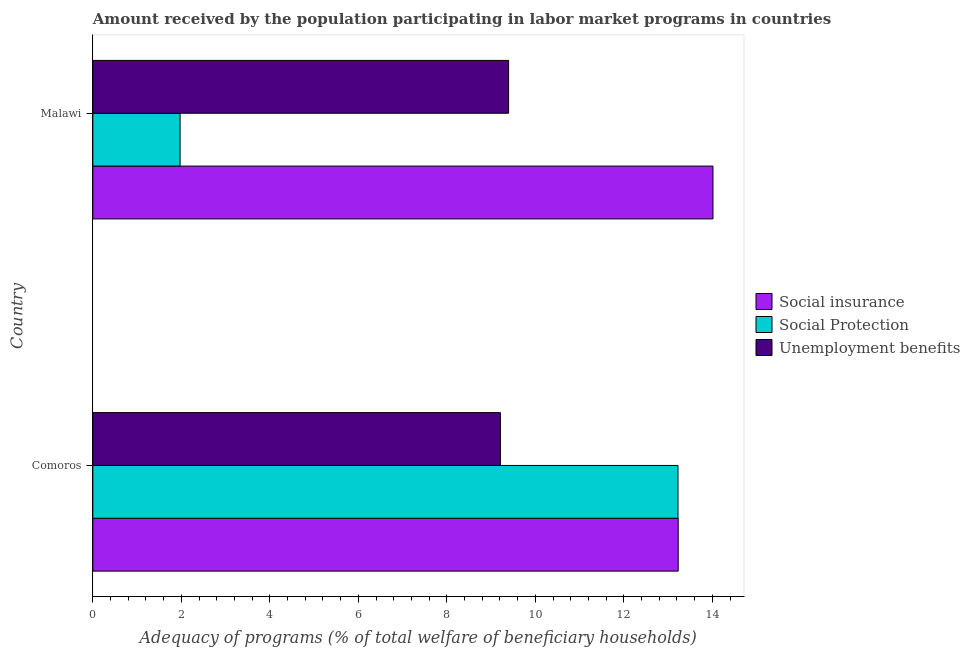How many different coloured bars are there?
Your answer should be compact. 3. How many groups of bars are there?
Keep it short and to the point. 2. Are the number of bars per tick equal to the number of legend labels?
Your answer should be very brief. Yes. How many bars are there on the 1st tick from the top?
Offer a terse response. 3. What is the label of the 1st group of bars from the top?
Offer a very short reply. Malawi. In how many cases, is the number of bars for a given country not equal to the number of legend labels?
Your answer should be very brief. 0. What is the amount received by the population participating in social protection programs in Malawi?
Offer a terse response. 1.97. Across all countries, what is the maximum amount received by the population participating in unemployment benefits programs?
Offer a very short reply. 9.4. Across all countries, what is the minimum amount received by the population participating in unemployment benefits programs?
Your response must be concise. 9.21. In which country was the amount received by the population participating in social protection programs maximum?
Make the answer very short. Comoros. In which country was the amount received by the population participating in social insurance programs minimum?
Your answer should be compact. Comoros. What is the total amount received by the population participating in unemployment benefits programs in the graph?
Make the answer very short. 18.61. What is the difference between the amount received by the population participating in unemployment benefits programs in Comoros and that in Malawi?
Make the answer very short. -0.19. What is the difference between the amount received by the population participating in social insurance programs in Comoros and the amount received by the population participating in unemployment benefits programs in Malawi?
Your answer should be compact. 3.83. What is the average amount received by the population participating in unemployment benefits programs per country?
Keep it short and to the point. 9.3. What is the difference between the amount received by the population participating in social protection programs and amount received by the population participating in unemployment benefits programs in Malawi?
Your answer should be very brief. -7.42. What is the ratio of the amount received by the population participating in social insurance programs in Comoros to that in Malawi?
Your answer should be compact. 0.94. Is the amount received by the population participating in social protection programs in Comoros less than that in Malawi?
Your answer should be compact. No. In how many countries, is the amount received by the population participating in social insurance programs greater than the average amount received by the population participating in social insurance programs taken over all countries?
Offer a very short reply. 1. What does the 2nd bar from the top in Comoros represents?
Your answer should be very brief. Social Protection. What does the 3rd bar from the bottom in Malawi represents?
Provide a short and direct response. Unemployment benefits. Are all the bars in the graph horizontal?
Offer a very short reply. Yes. How many countries are there in the graph?
Give a very brief answer. 2. Are the values on the major ticks of X-axis written in scientific E-notation?
Provide a short and direct response. No. Where does the legend appear in the graph?
Ensure brevity in your answer.  Center right. How are the legend labels stacked?
Provide a short and direct response. Vertical. What is the title of the graph?
Give a very brief answer. Amount received by the population participating in labor market programs in countries. Does "Social Protection and Labor" appear as one of the legend labels in the graph?
Offer a terse response. No. What is the label or title of the X-axis?
Your answer should be very brief. Adequacy of programs (% of total welfare of beneficiary households). What is the label or title of the Y-axis?
Give a very brief answer. Country. What is the Adequacy of programs (% of total welfare of beneficiary households) of Social insurance in Comoros?
Make the answer very short. 13.23. What is the Adequacy of programs (% of total welfare of beneficiary households) in Social Protection in Comoros?
Offer a very short reply. 13.22. What is the Adequacy of programs (% of total welfare of beneficiary households) in Unemployment benefits in Comoros?
Provide a short and direct response. 9.21. What is the Adequacy of programs (% of total welfare of beneficiary households) of Social insurance in Malawi?
Provide a succinct answer. 14.02. What is the Adequacy of programs (% of total welfare of beneficiary households) of Social Protection in Malawi?
Keep it short and to the point. 1.97. What is the Adequacy of programs (% of total welfare of beneficiary households) in Unemployment benefits in Malawi?
Your response must be concise. 9.4. Across all countries, what is the maximum Adequacy of programs (% of total welfare of beneficiary households) of Social insurance?
Provide a short and direct response. 14.02. Across all countries, what is the maximum Adequacy of programs (% of total welfare of beneficiary households) in Social Protection?
Your answer should be compact. 13.22. Across all countries, what is the maximum Adequacy of programs (% of total welfare of beneficiary households) of Unemployment benefits?
Ensure brevity in your answer.  9.4. Across all countries, what is the minimum Adequacy of programs (% of total welfare of beneficiary households) of Social insurance?
Provide a succinct answer. 13.23. Across all countries, what is the minimum Adequacy of programs (% of total welfare of beneficiary households) in Social Protection?
Ensure brevity in your answer.  1.97. Across all countries, what is the minimum Adequacy of programs (% of total welfare of beneficiary households) of Unemployment benefits?
Your response must be concise. 9.21. What is the total Adequacy of programs (% of total welfare of beneficiary households) of Social insurance in the graph?
Offer a terse response. 27.24. What is the total Adequacy of programs (% of total welfare of beneficiary households) in Social Protection in the graph?
Ensure brevity in your answer.  15.2. What is the total Adequacy of programs (% of total welfare of beneficiary households) in Unemployment benefits in the graph?
Ensure brevity in your answer.  18.61. What is the difference between the Adequacy of programs (% of total welfare of beneficiary households) in Social insurance in Comoros and that in Malawi?
Provide a succinct answer. -0.79. What is the difference between the Adequacy of programs (% of total welfare of beneficiary households) of Social Protection in Comoros and that in Malawi?
Give a very brief answer. 11.25. What is the difference between the Adequacy of programs (% of total welfare of beneficiary households) of Unemployment benefits in Comoros and that in Malawi?
Your response must be concise. -0.19. What is the difference between the Adequacy of programs (% of total welfare of beneficiary households) in Social insurance in Comoros and the Adequacy of programs (% of total welfare of beneficiary households) in Social Protection in Malawi?
Give a very brief answer. 11.26. What is the difference between the Adequacy of programs (% of total welfare of beneficiary households) of Social insurance in Comoros and the Adequacy of programs (% of total welfare of beneficiary households) of Unemployment benefits in Malawi?
Ensure brevity in your answer.  3.83. What is the difference between the Adequacy of programs (% of total welfare of beneficiary households) of Social Protection in Comoros and the Adequacy of programs (% of total welfare of beneficiary households) of Unemployment benefits in Malawi?
Keep it short and to the point. 3.83. What is the average Adequacy of programs (% of total welfare of beneficiary households) in Social insurance per country?
Provide a short and direct response. 13.62. What is the average Adequacy of programs (% of total welfare of beneficiary households) of Social Protection per country?
Your response must be concise. 7.6. What is the average Adequacy of programs (% of total welfare of beneficiary households) in Unemployment benefits per country?
Provide a short and direct response. 9.3. What is the difference between the Adequacy of programs (% of total welfare of beneficiary households) of Social insurance and Adequacy of programs (% of total welfare of beneficiary households) of Social Protection in Comoros?
Your answer should be compact. 0. What is the difference between the Adequacy of programs (% of total welfare of beneficiary households) of Social insurance and Adequacy of programs (% of total welfare of beneficiary households) of Unemployment benefits in Comoros?
Provide a succinct answer. 4.02. What is the difference between the Adequacy of programs (% of total welfare of beneficiary households) in Social Protection and Adequacy of programs (% of total welfare of beneficiary households) in Unemployment benefits in Comoros?
Your response must be concise. 4.01. What is the difference between the Adequacy of programs (% of total welfare of beneficiary households) of Social insurance and Adequacy of programs (% of total welfare of beneficiary households) of Social Protection in Malawi?
Your answer should be compact. 12.04. What is the difference between the Adequacy of programs (% of total welfare of beneficiary households) in Social insurance and Adequacy of programs (% of total welfare of beneficiary households) in Unemployment benefits in Malawi?
Your response must be concise. 4.62. What is the difference between the Adequacy of programs (% of total welfare of beneficiary households) of Social Protection and Adequacy of programs (% of total welfare of beneficiary households) of Unemployment benefits in Malawi?
Offer a very short reply. -7.42. What is the ratio of the Adequacy of programs (% of total welfare of beneficiary households) of Social insurance in Comoros to that in Malawi?
Your answer should be compact. 0.94. What is the ratio of the Adequacy of programs (% of total welfare of beneficiary households) of Social Protection in Comoros to that in Malawi?
Keep it short and to the point. 6.71. What is the ratio of the Adequacy of programs (% of total welfare of beneficiary households) in Unemployment benefits in Comoros to that in Malawi?
Keep it short and to the point. 0.98. What is the difference between the highest and the second highest Adequacy of programs (% of total welfare of beneficiary households) in Social insurance?
Offer a terse response. 0.79. What is the difference between the highest and the second highest Adequacy of programs (% of total welfare of beneficiary households) in Social Protection?
Give a very brief answer. 11.25. What is the difference between the highest and the second highest Adequacy of programs (% of total welfare of beneficiary households) in Unemployment benefits?
Ensure brevity in your answer.  0.19. What is the difference between the highest and the lowest Adequacy of programs (% of total welfare of beneficiary households) in Social insurance?
Provide a succinct answer. 0.79. What is the difference between the highest and the lowest Adequacy of programs (% of total welfare of beneficiary households) of Social Protection?
Your response must be concise. 11.25. What is the difference between the highest and the lowest Adequacy of programs (% of total welfare of beneficiary households) in Unemployment benefits?
Your answer should be compact. 0.19. 